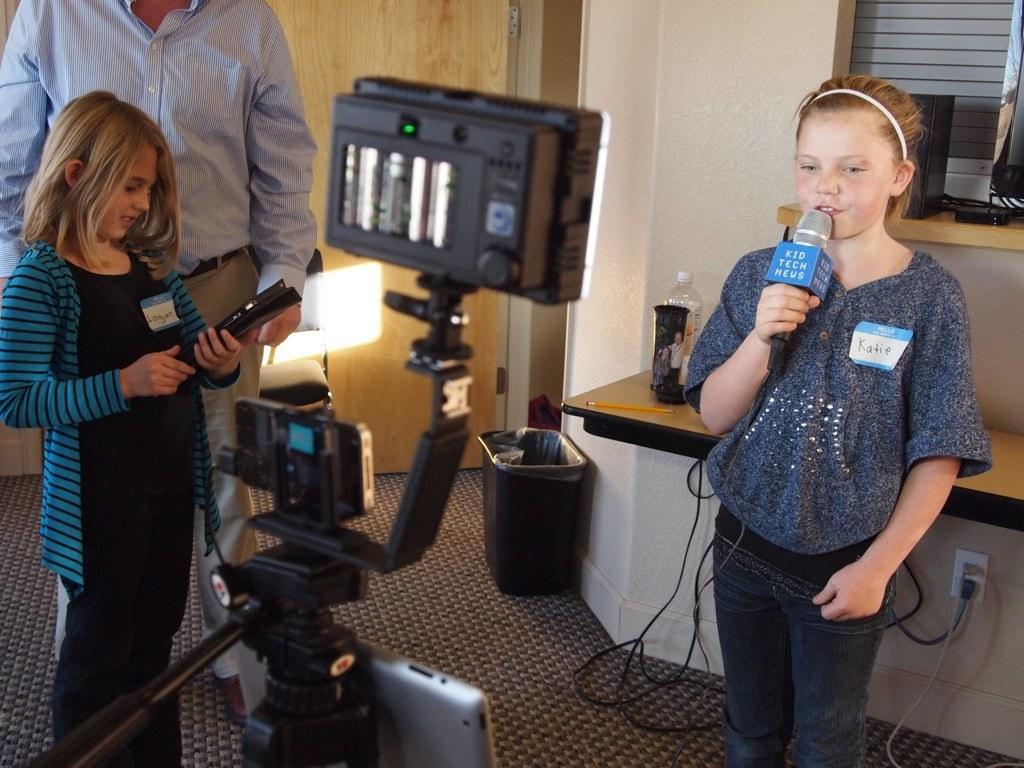How would you summarize this image in a sentence or two? This 3 persons are standing. This girl holds mic. This is a camera. On floor there is a bin. On this table there is a bottle and pencil. This girl wore blue jacket. On chair there is a light. Under the table there is a socket with cables. 